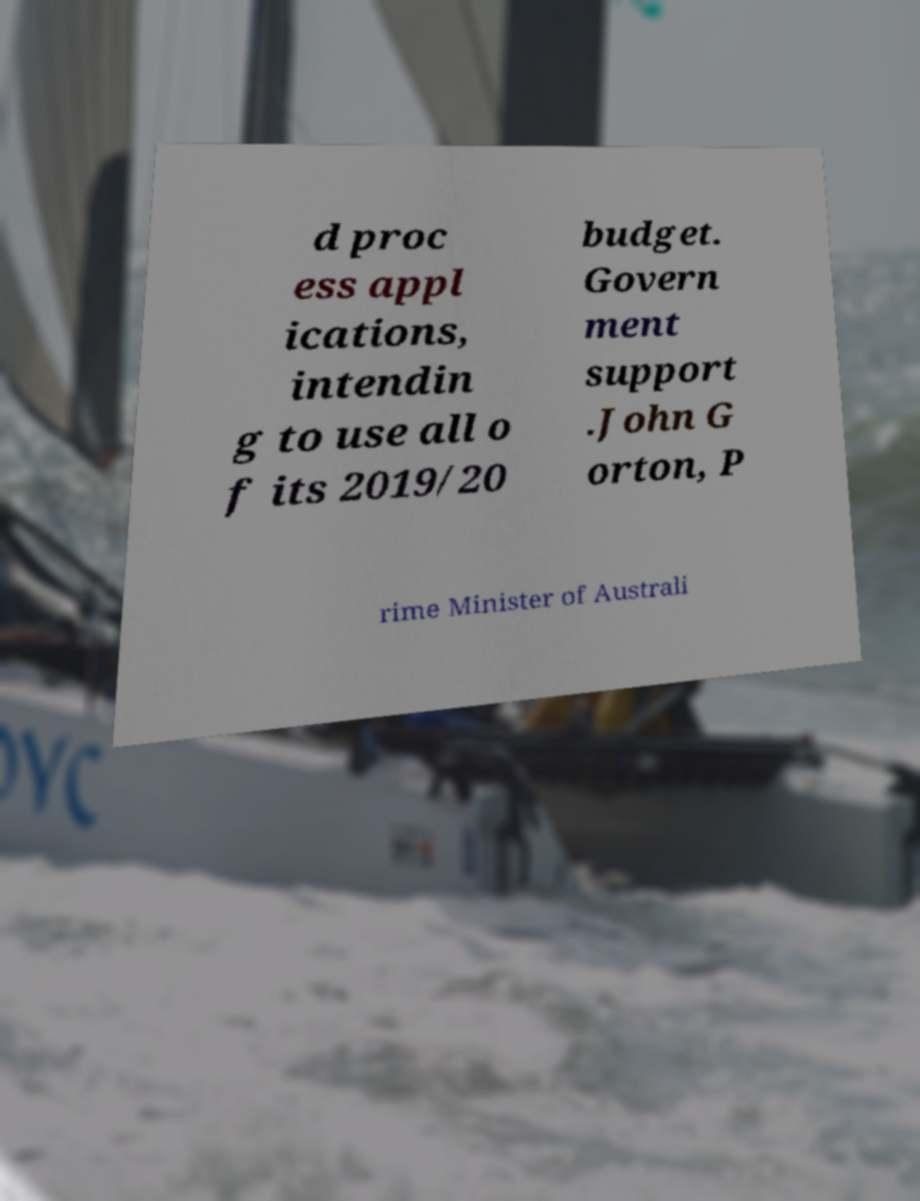Please identify and transcribe the text found in this image. d proc ess appl ications, intendin g to use all o f its 2019/20 budget. Govern ment support .John G orton, P rime Minister of Australi 